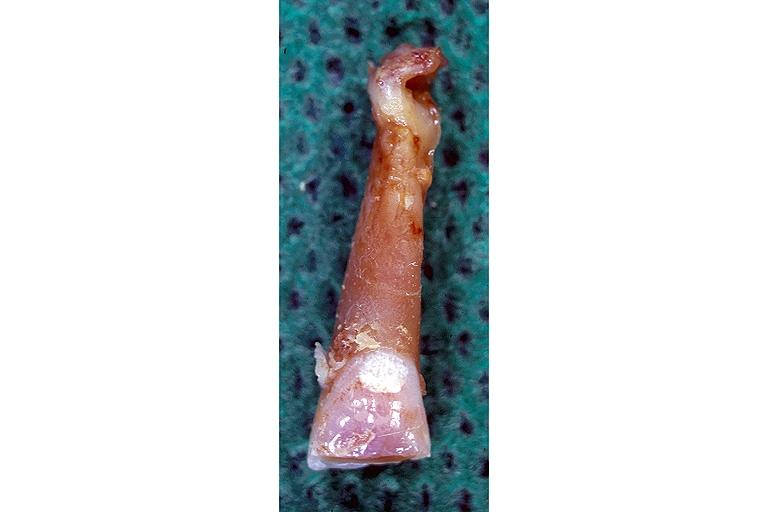s oral present?
Answer the question using a single word or phrase. Yes 